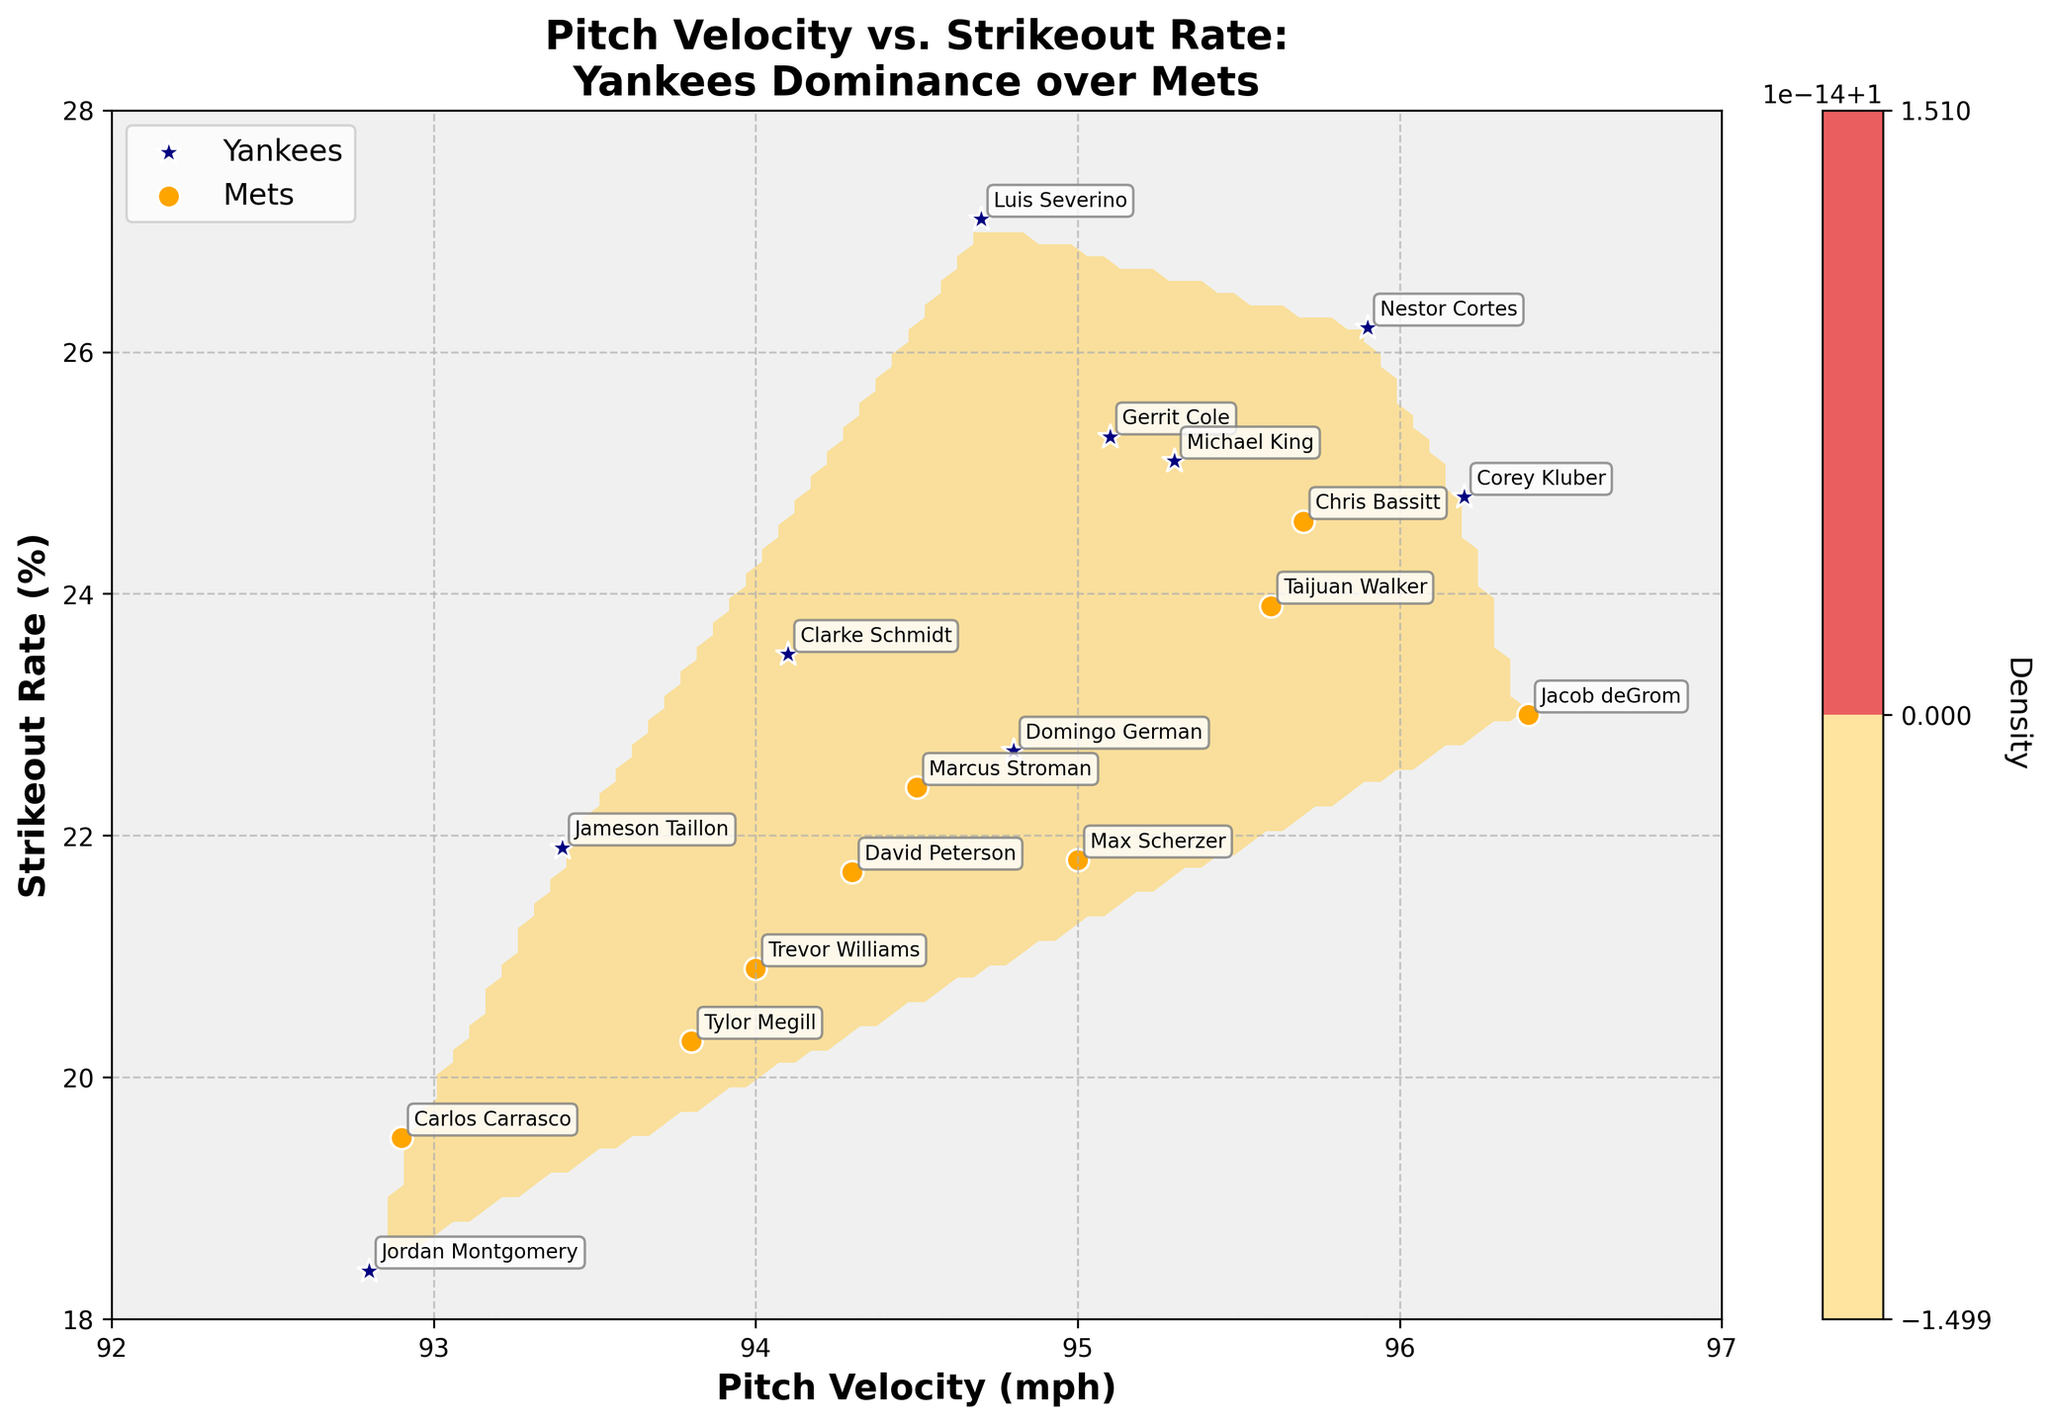What is the title of the plot? The title of the plot is typically found at the top center of a figure. In this case, the title explicitly mentions the comparison between Yankees and Mets pitchers.
Answer: Pitch Velocity vs. Strikeout Rate: Yankees Dominance over Mets What are the labels for the x-axis and the y-axis? The labels for the axes are found along the horizontal and vertical edges of the plot, describing the variables being plotted.
Answer: Pitch Velocity (mph) and Strikeout Rate (%) Which team has more scatter points represented on the plot? By counting the number of scatter points for the Yankees (blue stars) and Mets (orange circles), one can determine which has more pitchers represented.
Answer: Yankees Who is the Yankees pitcher with the highest strikeout rate? By observing the scatter points labeled with player names and identifying the highest position on the y-axis within the Yankees pitchers, one can determine this.
Answer: Luis Severino What is the approximate strikeout rate for Mets pitcher Jacob deGrom? Locate Jacob deGrom's point on the plot, read his strikeout rate from the y-axis or the adjacent contour lines.
Answer: 23.0% Who has a faster pitch velocity, Gerrit Cole or Max Scherzer? Compare the x-axis values of the points labeled Gerrit Cole and Max Scherzer. Gerrit Cole's point is further to the right.
Answer: Gerrit Cole Which team has higher density according to the contour plot? Observe the color intensity within contours for Yankees and Mets regions. The higher density will be prominently marked by color intensity variations.
Answer: Yankees What range of pitch velocities is covered by the contour plot? By looking at the x-axis limits of the plot, one can determine the range of pitch velocities.
Answer: 92 to 97 mph Which pitcher from the Mets has the lowest strikeout rate? By checking the lowest y-axis position among the points labeled with Mets players' names, the pitcher can be identified.
Answer: Carlos Carrasco What is the average pitch velocity for Yankees pitchers? Extract the pitch velocities for all Yankees pitchers, sum them up, and divide by the number of pitchers. (95.1 + 94.7 + 93.4 + 92.8 + 96.2 + 95.9 + 94.8 + 94.1 + 95.3) / 9 = 94.81 mph.
Answer: 94.81 mph 